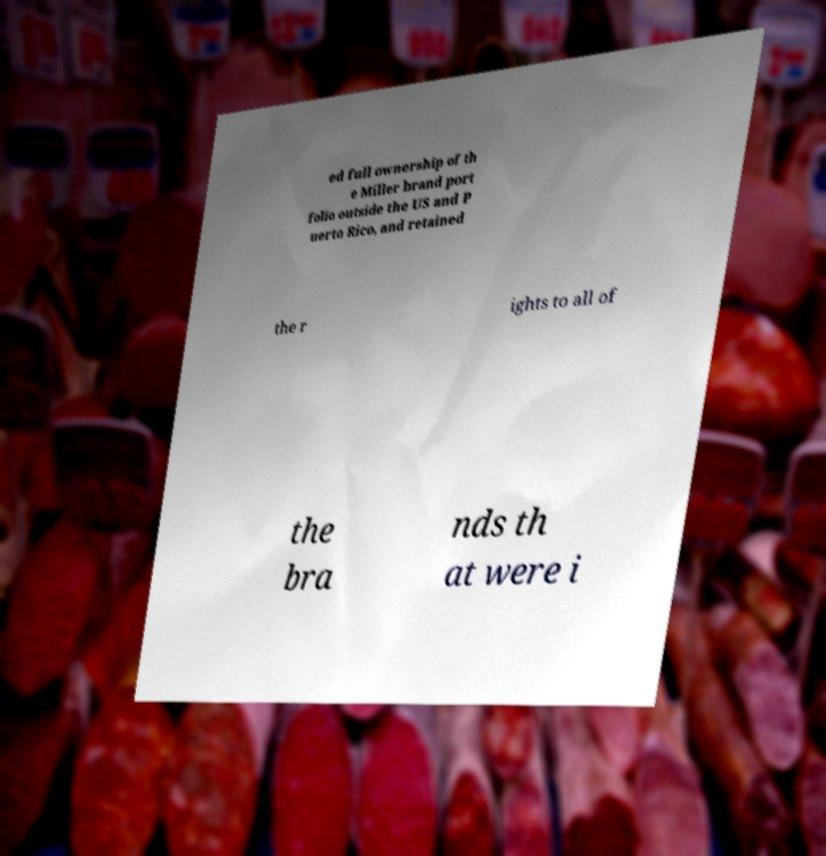There's text embedded in this image that I need extracted. Can you transcribe it verbatim? ed full ownership of th e Miller brand port folio outside the US and P uerto Rico, and retained the r ights to all of the bra nds th at were i 